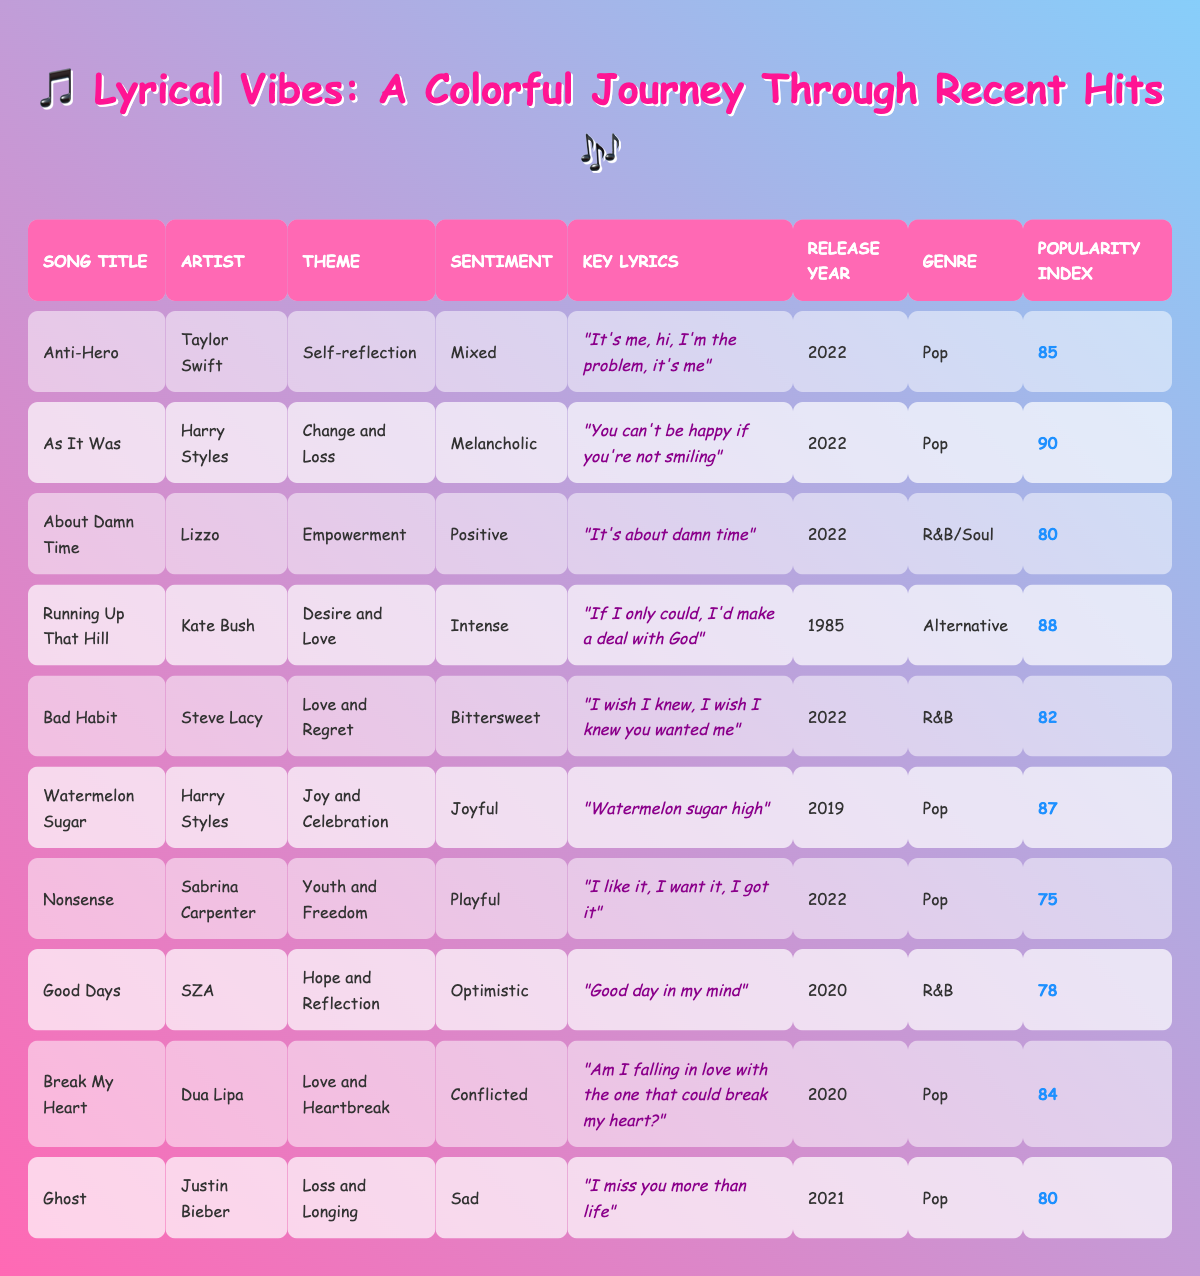What is the theme of the song "Ghost"? The table shows that the song "Ghost" by Justin Bieber has the theme "Loss and Longing".
Answer: Loss and Longing Which artist performed the song with the highest popularity index? By examining the Popularity Index column, "As It Was" by Harry Styles has the highest index at 90.
Answer: Harry Styles How many songs were released in 2022? Counting the rows for the Release Year of 2022, we find there are five songs: "Anti-Hero," "As It Was," "About Damn Time," "Bad Habit," and "Nonsense."
Answer: 5 What are the sentiments of the songs that have the theme of love? The songs related to love themes are "Running Up That Hill" (Intense), "Bad Habit" (Bittersweet), "Break My Heart" (Conflicted), and "Ghost" (Sad). Therefore, the sentiments are Intense, Bittersweet, Conflicted, and Sad.
Answer: Intense, Bittersweet, Conflicted, Sad Is there a song with a positive sentiment that has the theme of empowerment? The song "About Damn Time" by Lizzo fits both criteria as it has a theme of empowerment and a positive sentiment.
Answer: Yes What is the average popularity index of the R&B songs in the table? The R&B songs are "About Damn Time" (80), "Bad Habit" (82), "Good Days" (78). The sum is (80 + 82 + 78 = 240), and there are 3 songs, so the average is 240/3 = 80.
Answer: 80 Which song has the most joyful sentiment and what are its key lyrics? The song "Watermelon Sugar" by Harry Styles has a joyful sentiment and the key lyrics are "Watermelon sugar high."
Answer: Watermelon Sugar; "Watermelon sugar high" How many songs have a melancholic sentiment? From the table, only "As It Was" by Harry Styles has a melancholic sentiment. Therefore, there is only one such song.
Answer: 1 What year was the song "Running Up That Hill" released? The Release Year column shows that "Running Up That Hill" was released in 1985.
Answer: 1985 Which genre has the most songs listed in the table? By counting the genres, "Pop" appears most frequently with five songs: "Anti-Hero," "As It Was," "Watermelon Sugar," "Nonsense," and "Ghost."
Answer: Pop 